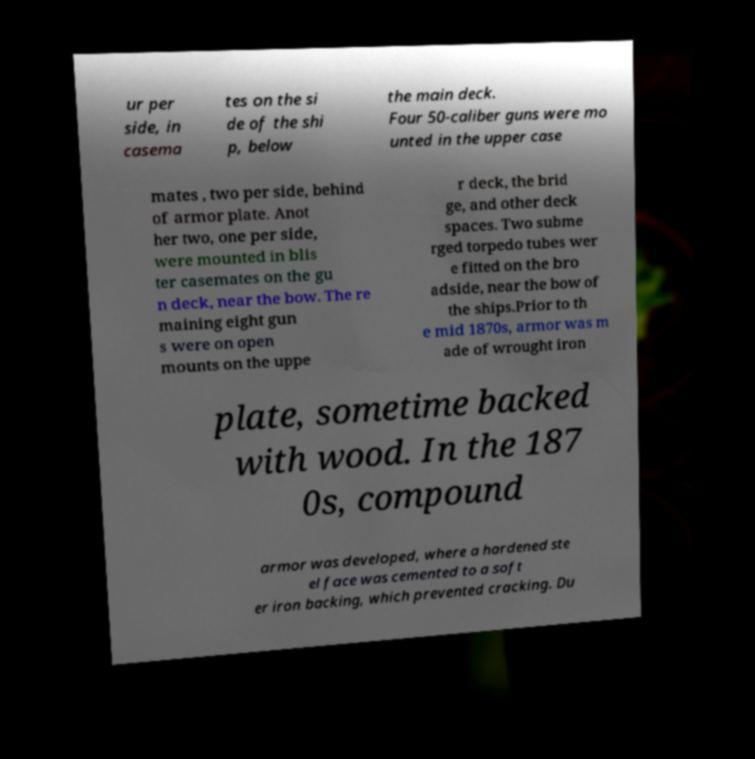Please identify and transcribe the text found in this image. ur per side, in casema tes on the si de of the shi p, below the main deck. Four 50-caliber guns were mo unted in the upper case mates , two per side, behind of armor plate. Anot her two, one per side, were mounted in blis ter casemates on the gu n deck, near the bow. The re maining eight gun s were on open mounts on the uppe r deck, the brid ge, and other deck spaces. Two subme rged torpedo tubes wer e fitted on the bro adside, near the bow of the ships.Prior to th e mid 1870s, armor was m ade of wrought iron plate, sometime backed with wood. In the 187 0s, compound armor was developed, where a hardened ste el face was cemented to a soft er iron backing, which prevented cracking. Du 